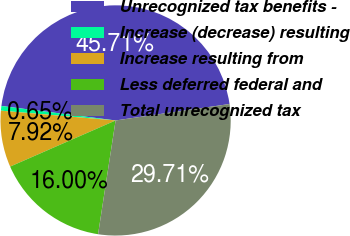Convert chart to OTSL. <chart><loc_0><loc_0><loc_500><loc_500><pie_chart><fcel>Unrecognized tax benefits -<fcel>Increase (decrease) resulting<fcel>Increase resulting from<fcel>Less deferred federal and<fcel>Total unrecognized tax<nl><fcel>45.71%<fcel>0.65%<fcel>7.92%<fcel>16.0%<fcel>29.71%<nl></chart> 